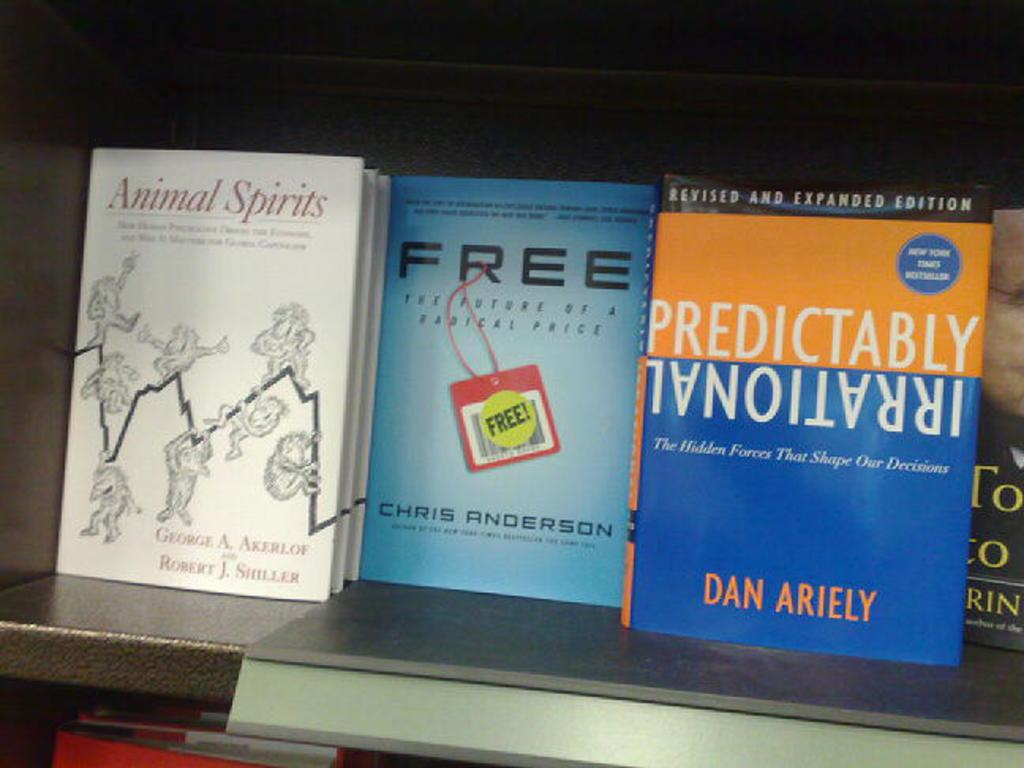Provide a one-sentence caption for the provided image. A shelf with several books titles including on titles Free. 